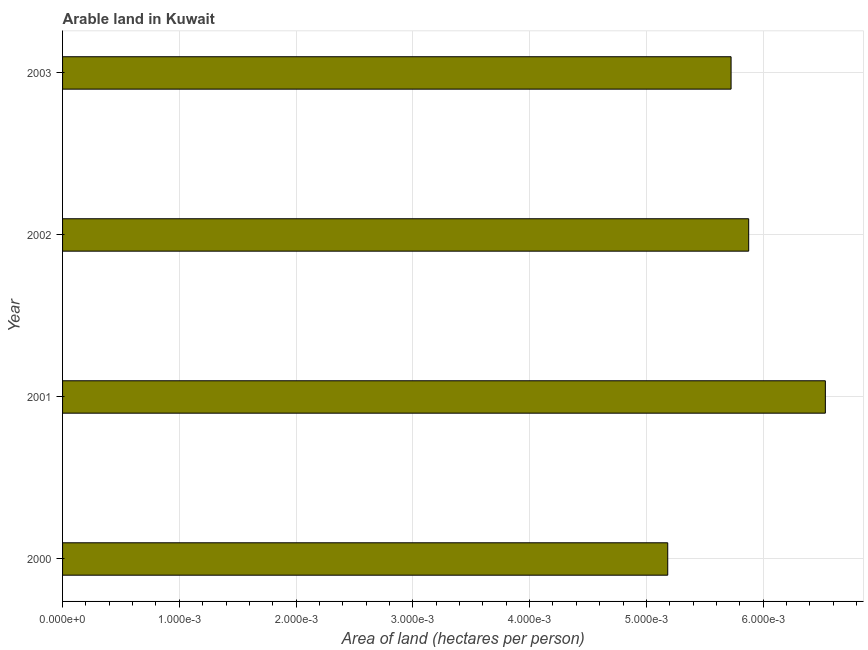What is the title of the graph?
Offer a terse response. Arable land in Kuwait. What is the label or title of the X-axis?
Give a very brief answer. Area of land (hectares per person). What is the label or title of the Y-axis?
Ensure brevity in your answer.  Year. What is the area of arable land in 2000?
Offer a very short reply. 0.01. Across all years, what is the maximum area of arable land?
Give a very brief answer. 0.01. Across all years, what is the minimum area of arable land?
Ensure brevity in your answer.  0.01. In which year was the area of arable land maximum?
Provide a short and direct response. 2001. What is the sum of the area of arable land?
Provide a short and direct response. 0.02. What is the difference between the area of arable land in 2000 and 2001?
Give a very brief answer. -0. What is the average area of arable land per year?
Offer a very short reply. 0.01. What is the median area of arable land?
Keep it short and to the point. 0.01. Is the area of arable land in 2002 less than that in 2003?
Keep it short and to the point. No. Is the difference between the area of arable land in 2002 and 2003 greater than the difference between any two years?
Give a very brief answer. No. What is the difference between the highest and the second highest area of arable land?
Keep it short and to the point. 0. Is the sum of the area of arable land in 2001 and 2003 greater than the maximum area of arable land across all years?
Your answer should be very brief. Yes. What is the difference between the highest and the lowest area of arable land?
Provide a succinct answer. 0. How many bars are there?
Provide a succinct answer. 4. Are all the bars in the graph horizontal?
Offer a very short reply. Yes. How many years are there in the graph?
Make the answer very short. 4. What is the difference between two consecutive major ticks on the X-axis?
Provide a succinct answer. 0. What is the Area of land (hectares per person) of 2000?
Provide a succinct answer. 0.01. What is the Area of land (hectares per person) in 2001?
Provide a short and direct response. 0.01. What is the Area of land (hectares per person) of 2002?
Provide a succinct answer. 0.01. What is the Area of land (hectares per person) of 2003?
Ensure brevity in your answer.  0.01. What is the difference between the Area of land (hectares per person) in 2000 and 2001?
Provide a short and direct response. -0. What is the difference between the Area of land (hectares per person) in 2000 and 2002?
Provide a succinct answer. -0. What is the difference between the Area of land (hectares per person) in 2000 and 2003?
Provide a succinct answer. -0. What is the difference between the Area of land (hectares per person) in 2001 and 2002?
Your answer should be very brief. 0. What is the difference between the Area of land (hectares per person) in 2001 and 2003?
Offer a very short reply. 0. What is the difference between the Area of land (hectares per person) in 2002 and 2003?
Your answer should be compact. 0. What is the ratio of the Area of land (hectares per person) in 2000 to that in 2001?
Your answer should be very brief. 0.79. What is the ratio of the Area of land (hectares per person) in 2000 to that in 2002?
Provide a short and direct response. 0.88. What is the ratio of the Area of land (hectares per person) in 2000 to that in 2003?
Your answer should be compact. 0.91. What is the ratio of the Area of land (hectares per person) in 2001 to that in 2002?
Your answer should be very brief. 1.11. What is the ratio of the Area of land (hectares per person) in 2001 to that in 2003?
Keep it short and to the point. 1.14. What is the ratio of the Area of land (hectares per person) in 2002 to that in 2003?
Give a very brief answer. 1.03. 